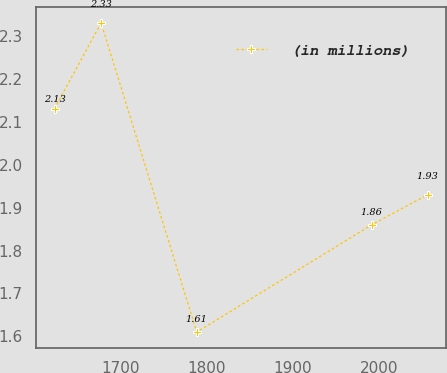Convert chart. <chart><loc_0><loc_0><loc_500><loc_500><line_chart><ecel><fcel>(in millions)<nl><fcel>1623.17<fcel>2.13<nl><fcel>1677.26<fcel>2.33<nl><fcel>1788.38<fcel>1.61<nl><fcel>1991.54<fcel>1.86<nl><fcel>2056.53<fcel>1.93<nl></chart> 